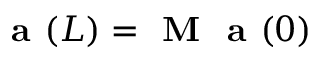Convert formula to latex. <formula><loc_0><loc_0><loc_500><loc_500>a ( L ) = M a ( 0 )</formula> 